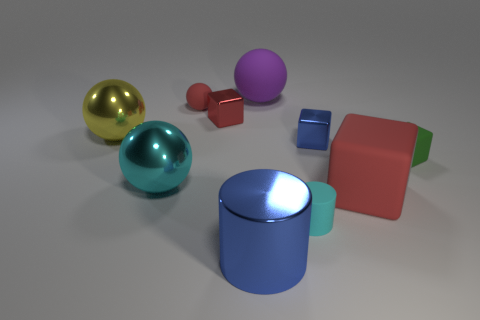Subtract 1 balls. How many balls are left? 3 Subtract all blocks. How many objects are left? 6 Subtract 0 red cylinders. How many objects are left? 10 Subtract all big purple rubber spheres. Subtract all blue metallic objects. How many objects are left? 7 Add 1 big yellow objects. How many big yellow objects are left? 2 Add 10 big gray shiny balls. How many big gray shiny balls exist? 10 